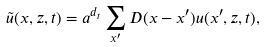<formula> <loc_0><loc_0><loc_500><loc_500>\tilde { u } ( { x } , { z } , t ) = a ^ { d _ { t } } \sum _ { { x } ^ { \prime } } D ( { x } - { x ^ { \prime } } ) { u } ( { x ^ { \prime } } , { z } , t ) ,</formula> 